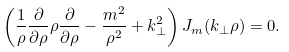Convert formula to latex. <formula><loc_0><loc_0><loc_500><loc_500>\left ( \frac { 1 } { \rho } \frac { \partial } { \partial \rho } \rho \frac { \partial } { \partial \rho } - \frac { m ^ { 2 } } { \rho ^ { 2 } } + k _ { \perp } ^ { 2 } \right ) J _ { m } ( k _ { \perp } \rho ) = 0 .</formula> 